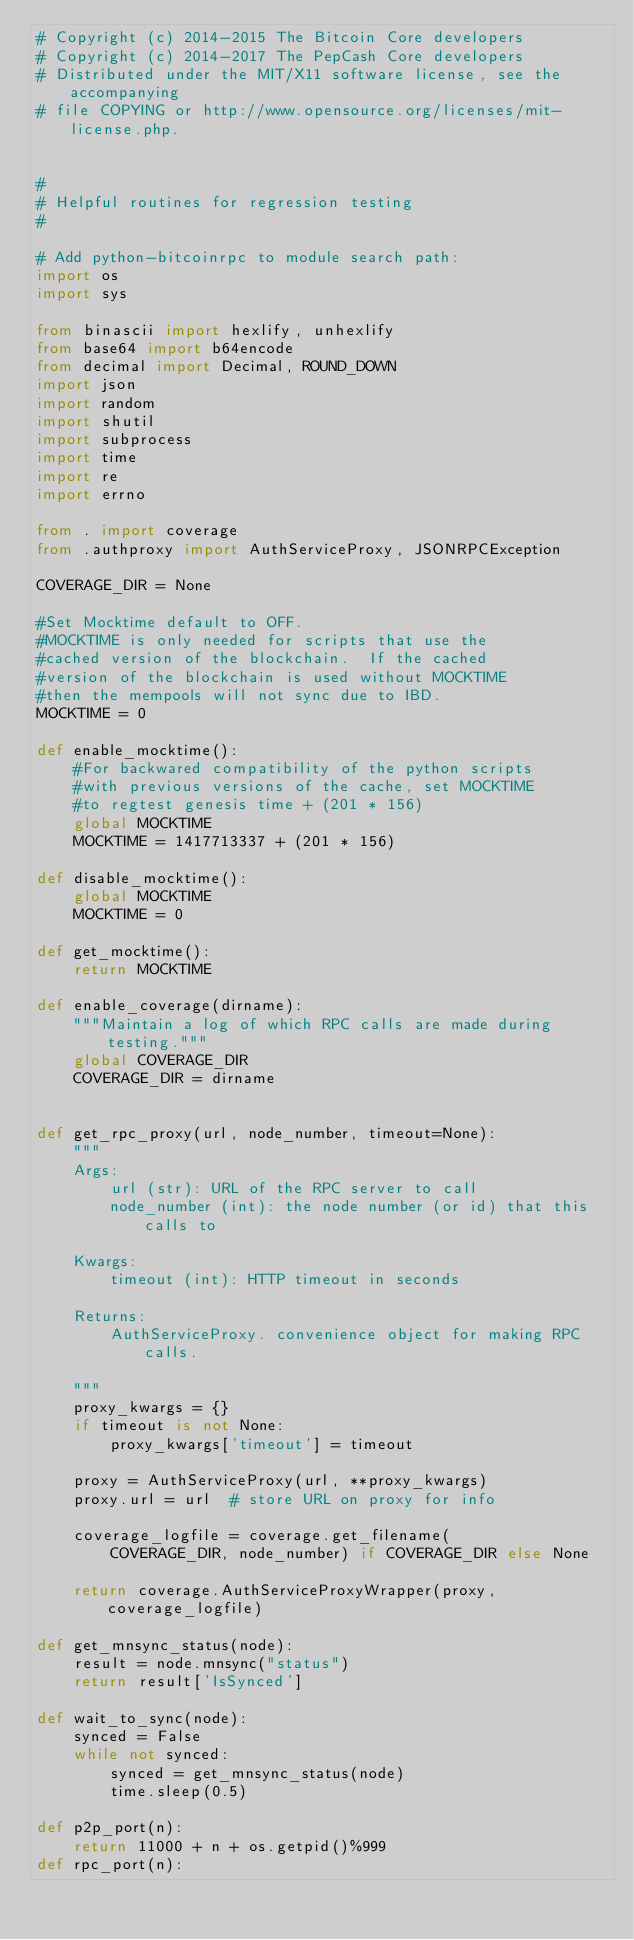Convert code to text. <code><loc_0><loc_0><loc_500><loc_500><_Python_># Copyright (c) 2014-2015 The Bitcoin Core developers
# Copyright (c) 2014-2017 The PepCash Core developers
# Distributed under the MIT/X11 software license, see the accompanying
# file COPYING or http://www.opensource.org/licenses/mit-license.php.


#
# Helpful routines for regression testing
#

# Add python-bitcoinrpc to module search path:
import os
import sys

from binascii import hexlify, unhexlify
from base64 import b64encode
from decimal import Decimal, ROUND_DOWN
import json
import random
import shutil
import subprocess
import time
import re
import errno

from . import coverage
from .authproxy import AuthServiceProxy, JSONRPCException

COVERAGE_DIR = None

#Set Mocktime default to OFF.
#MOCKTIME is only needed for scripts that use the
#cached version of the blockchain.  If the cached
#version of the blockchain is used without MOCKTIME
#then the mempools will not sync due to IBD.
MOCKTIME = 0

def enable_mocktime():
    #For backwared compatibility of the python scripts
    #with previous versions of the cache, set MOCKTIME 
    #to regtest genesis time + (201 * 156)
    global MOCKTIME
    MOCKTIME = 1417713337 + (201 * 156)

def disable_mocktime():
    global MOCKTIME
    MOCKTIME = 0

def get_mocktime():
    return MOCKTIME

def enable_coverage(dirname):
    """Maintain a log of which RPC calls are made during testing."""
    global COVERAGE_DIR
    COVERAGE_DIR = dirname


def get_rpc_proxy(url, node_number, timeout=None):
    """
    Args:
        url (str): URL of the RPC server to call
        node_number (int): the node number (or id) that this calls to

    Kwargs:
        timeout (int): HTTP timeout in seconds

    Returns:
        AuthServiceProxy. convenience object for making RPC calls.

    """
    proxy_kwargs = {}
    if timeout is not None:
        proxy_kwargs['timeout'] = timeout

    proxy = AuthServiceProxy(url, **proxy_kwargs)
    proxy.url = url  # store URL on proxy for info

    coverage_logfile = coverage.get_filename(
        COVERAGE_DIR, node_number) if COVERAGE_DIR else None

    return coverage.AuthServiceProxyWrapper(proxy, coverage_logfile)

def get_mnsync_status(node):
    result = node.mnsync("status")
    return result['IsSynced']

def wait_to_sync(node):
    synced = False
    while not synced:
        synced = get_mnsync_status(node)
        time.sleep(0.5)

def p2p_port(n):
    return 11000 + n + os.getpid()%999
def rpc_port(n):</code> 